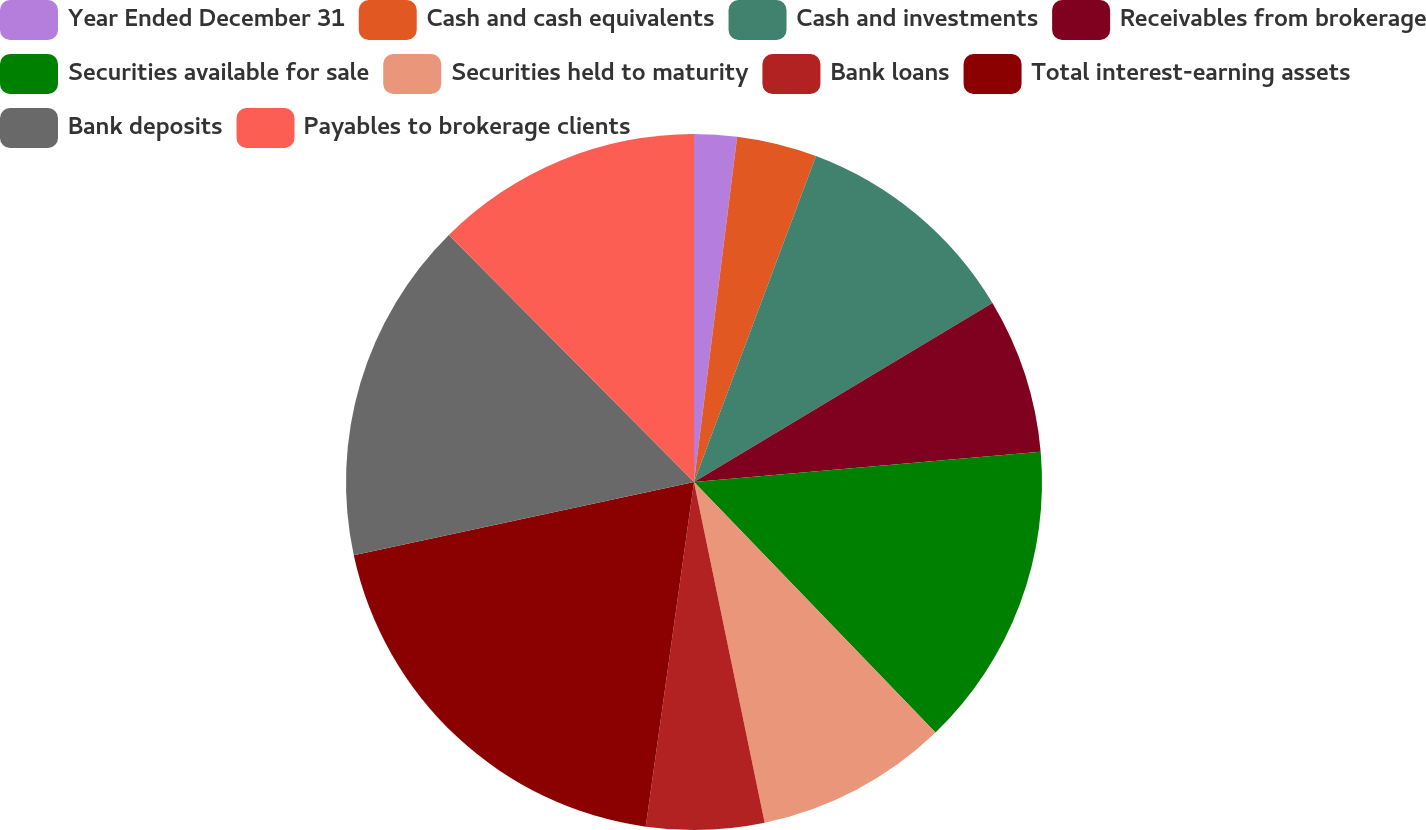<chart> <loc_0><loc_0><loc_500><loc_500><pie_chart><fcel>Year Ended December 31<fcel>Cash and cash equivalents<fcel>Cash and investments<fcel>Receivables from brokerage<fcel>Securities available for sale<fcel>Securities held to maturity<fcel>Bank loans<fcel>Total interest-earning assets<fcel>Bank deposits<fcel>Payables to brokerage clients<nl><fcel>1.98%<fcel>3.72%<fcel>10.7%<fcel>7.21%<fcel>14.18%<fcel>8.95%<fcel>5.47%<fcel>19.41%<fcel>15.93%<fcel>12.44%<nl></chart> 